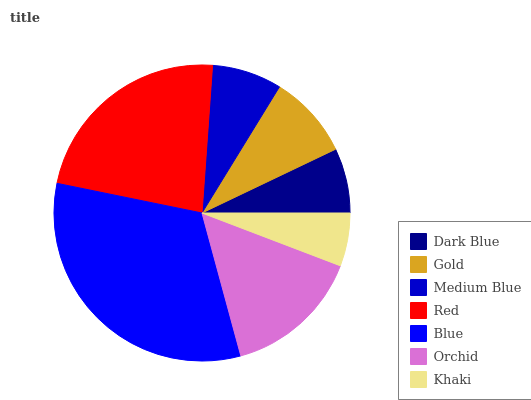Is Khaki the minimum?
Answer yes or no. Yes. Is Blue the maximum?
Answer yes or no. Yes. Is Gold the minimum?
Answer yes or no. No. Is Gold the maximum?
Answer yes or no. No. Is Gold greater than Dark Blue?
Answer yes or no. Yes. Is Dark Blue less than Gold?
Answer yes or no. Yes. Is Dark Blue greater than Gold?
Answer yes or no. No. Is Gold less than Dark Blue?
Answer yes or no. No. Is Gold the high median?
Answer yes or no. Yes. Is Gold the low median?
Answer yes or no. Yes. Is Orchid the high median?
Answer yes or no. No. Is Red the low median?
Answer yes or no. No. 